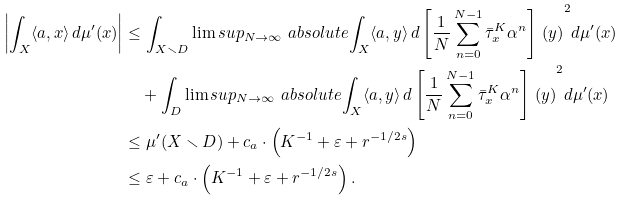<formula> <loc_0><loc_0><loc_500><loc_500>\left | \int _ { X } \langle a , x \rangle \, d \mu ^ { \prime } ( x ) \right | & \leq \int _ { X \smallsetminus D } \lim s u p _ { N \to \infty } \ a b s o l u t e { \int _ { X } \langle a , y \rangle \, d \left [ \frac { 1 } { N } \sum _ { n = 0 } ^ { N - 1 } \bar { \tau } _ { x } ^ { K } \alpha ^ { n } \right ] \, ( y ) } ^ { 2 } d \mu ^ { \prime } ( x ) \\ & \quad + \int _ { D } \lim s u p _ { N \to \infty } \ a b s o l u t e { \int _ { X } \langle a , y \rangle \, d \left [ \frac { 1 } { N } \sum _ { n = 0 } ^ { N - 1 } \bar { \tau } _ { x } ^ { K } \alpha ^ { n } \right ] \, ( y ) } ^ { 2 } d \mu ^ { \prime } ( x ) \\ & \leq \mu ^ { \prime } ( X \smallsetminus D ) + c _ { a } \cdot \left ( K ^ { - 1 } + \varepsilon + r ^ { - 1 / 2 s } \right ) \\ & \leq \varepsilon + c _ { a } \cdot \left ( K ^ { - 1 } + \varepsilon + r ^ { - 1 / 2 s } \right ) .</formula> 